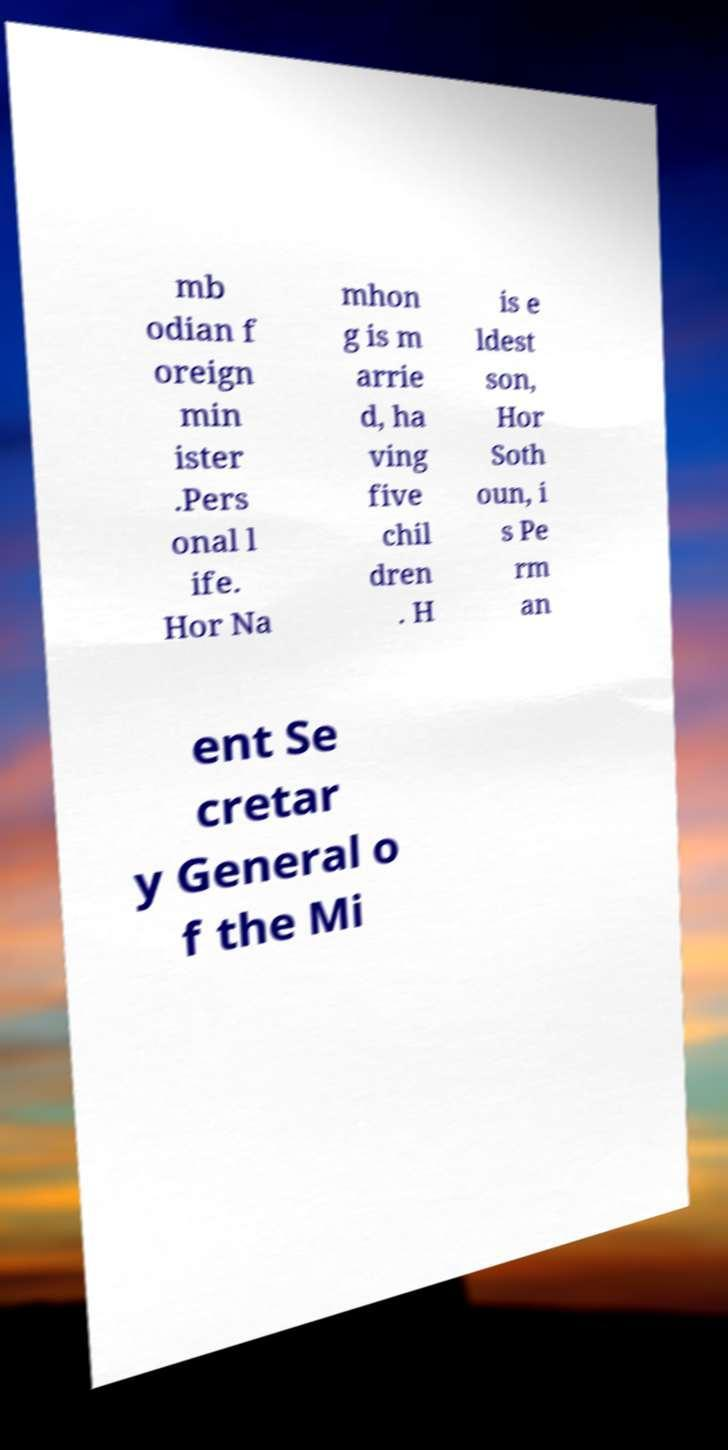Can you read and provide the text displayed in the image?This photo seems to have some interesting text. Can you extract and type it out for me? mb odian f oreign min ister .Pers onal l ife. Hor Na mhon g is m arrie d, ha ving five chil dren . H is e ldest son, Hor Soth oun, i s Pe rm an ent Se cretar y General o f the Mi 